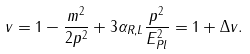Convert formula to latex. <formula><loc_0><loc_0><loc_500><loc_500>v = 1 - \frac { m ^ { 2 } } { 2 p ^ { 2 } } + 3 \alpha _ { R , L } \frac { p ^ { 2 } } { E _ { P l } ^ { 2 } } = 1 + \Delta v .</formula> 